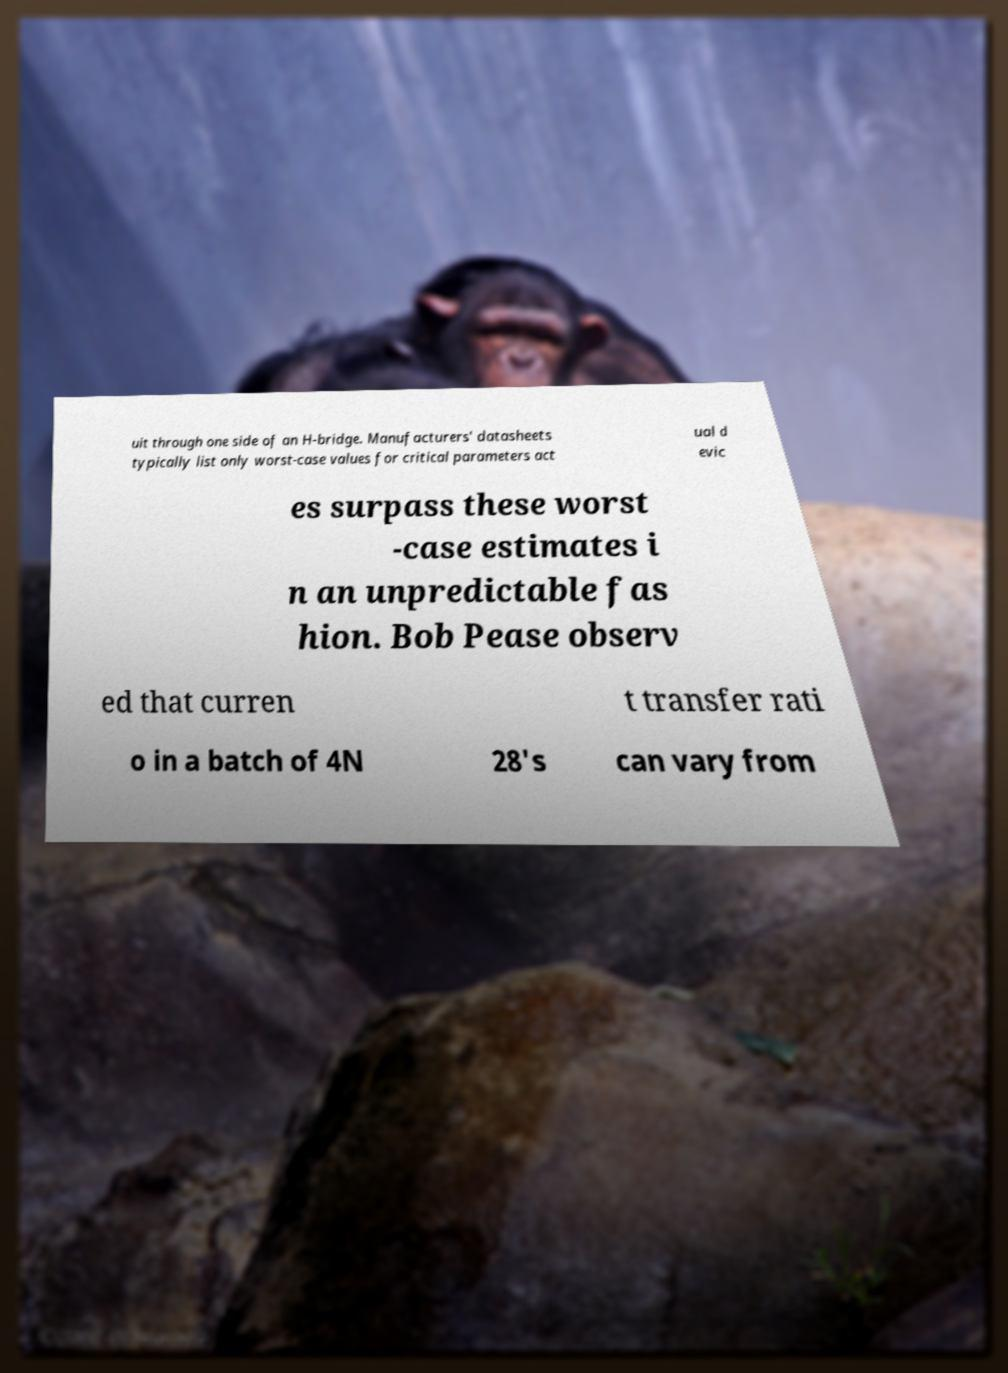Can you accurately transcribe the text from the provided image for me? uit through one side of an H-bridge. Manufacturers' datasheets typically list only worst-case values for critical parameters act ual d evic es surpass these worst -case estimates i n an unpredictable fas hion. Bob Pease observ ed that curren t transfer rati o in a batch of 4N 28's can vary from 